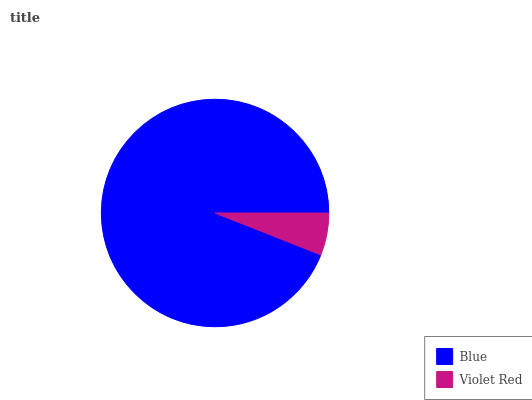Is Violet Red the minimum?
Answer yes or no. Yes. Is Blue the maximum?
Answer yes or no. Yes. Is Violet Red the maximum?
Answer yes or no. No. Is Blue greater than Violet Red?
Answer yes or no. Yes. Is Violet Red less than Blue?
Answer yes or no. Yes. Is Violet Red greater than Blue?
Answer yes or no. No. Is Blue less than Violet Red?
Answer yes or no. No. Is Blue the high median?
Answer yes or no. Yes. Is Violet Red the low median?
Answer yes or no. Yes. Is Violet Red the high median?
Answer yes or no. No. Is Blue the low median?
Answer yes or no. No. 